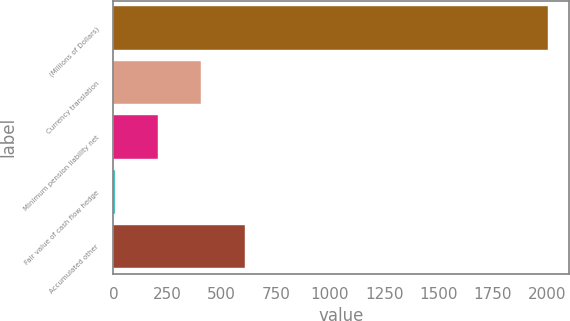Convert chart. <chart><loc_0><loc_0><loc_500><loc_500><bar_chart><fcel>(Millions of Dollars)<fcel>Currency translation<fcel>Minimum pension liability net<fcel>Fair value of cash flow hedge<fcel>Accumulated other<nl><fcel>2004<fcel>406.56<fcel>206.88<fcel>7.2<fcel>606.24<nl></chart> 